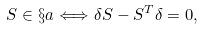<formula> <loc_0><loc_0><loc_500><loc_500>S \in \S a \Longleftrightarrow \delta S - S ^ { T } \delta = 0 ,</formula> 